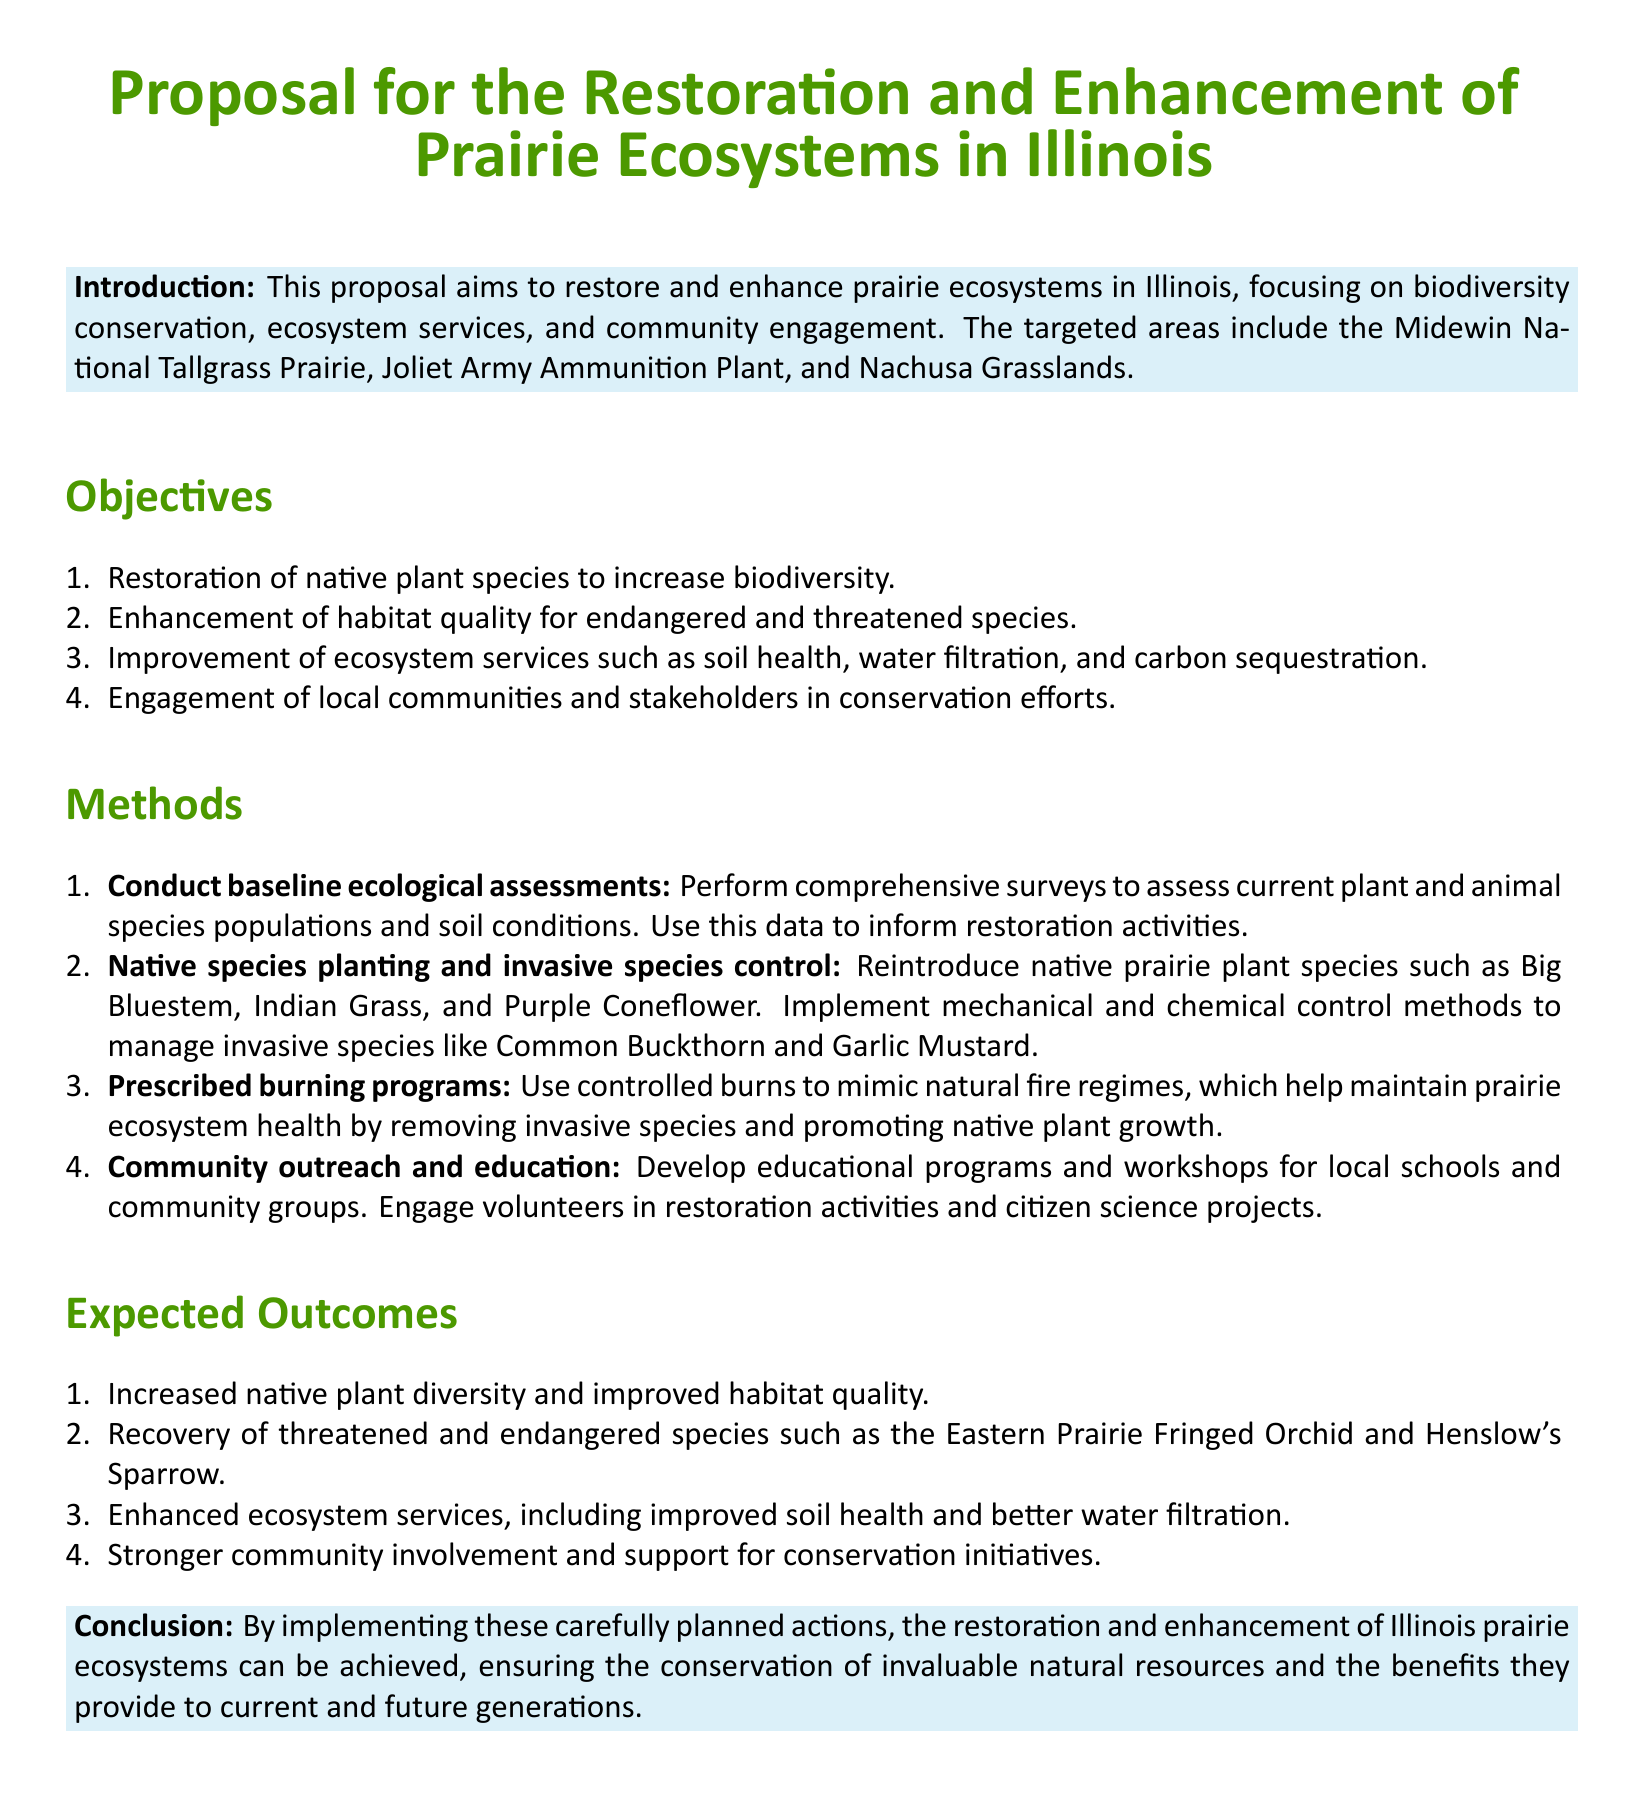What are the targeted areas for restoration? The targeted areas for restoration include the Midewin National Tallgrass Prairie, Joliet Army Ammunition Plant, and Nachusa Grasslands.
Answer: Midewin National Tallgrass Prairie, Joliet Army Ammunition Plant, Nachusa Grasslands What is one of the objectives of the proposal? One of the objectives of the proposal is to increase biodiversity through the restoration of native plant species.
Answer: Increase biodiversity What is one method proposed for enhancing habitat quality? The proposal suggests reintroducing native prairie plant species and implementing control methods for invasive species to enhance habitat quality.
Answer: Reintroducing native prairie plant species Which species is mentioned as threatened? The Eastern Prairie Fringed Orchid is mentioned as a threatened species in the expected outcomes of the proposal.
Answer: Eastern Prairie Fringed Orchid What type of programs are included in community outreach? Educational programs and workshops for local schools and community groups are included in the community outreach efforts.
Answer: Educational programs and workshops What is a key expected outcome related to community involvement? A key expected outcome is stronger community involvement and support for conservation initiatives.
Answer: Stronger community involvement What approach does the proposal recommend for weed management? The proposal recommends mechanical and chemical control methods for managing invasive species.
Answer: Mechanical and chemical control methods What ecosystem service is expected to improve? Improved soil health is one of the expected outcomes regarding ecosystem services.
Answer: Improved soil health 